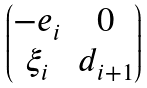Convert formula to latex. <formula><loc_0><loc_0><loc_500><loc_500>\begin{pmatrix} - e _ { i } & 0 \\ \xi _ { i } & d _ { i + 1 } \end{pmatrix}</formula> 